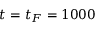Convert formula to latex. <formula><loc_0><loc_0><loc_500><loc_500>t = t _ { F } = 1 0 0 0</formula> 